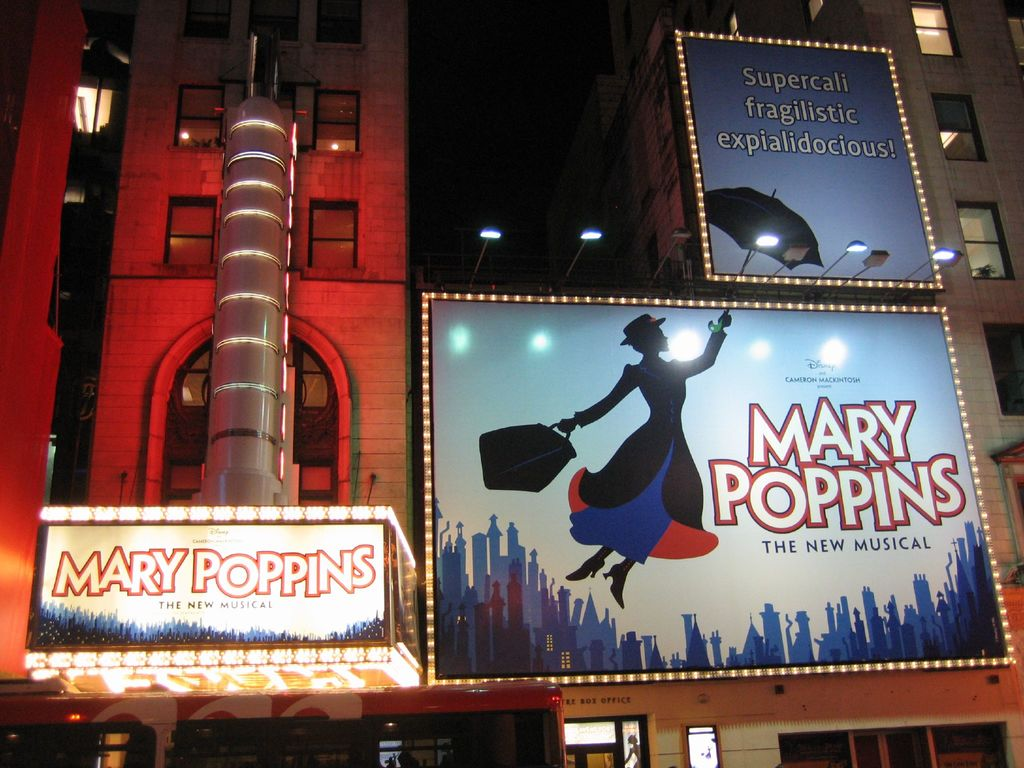What might be the significance of using such vibrant lighting and large billboards for this musical? The vibrant lighting and large billboards play a crucial role in creating a visual allure that captures the attention of passersby and potential audience members. This theatrical marketing strategy not only highlights the musical's presence in a bustling cityscape but also reflects the magical and larger-than-life aspects of the 'Mary Poppins' narrative. Such display tactics evoke excitement and curiosity, drawing in audiences with the promise of a spectacular production that mirrors the enchantment depicted on the billboards. How does this kind of marketing affect audience expectations? This type of marketing sets high audience expectations, as the grandiose and vivid displays suggest an equally impressive theatrical experience. By showcasing key elements of the story and its whimsical themes through dynamic and eye-catching visuals, the marketing ensures that the audience is primed for a high-quality, engaging, and memorable performance that will likely resonate emotionally and aesthetically, aligning with the iconic status of 'Mary Poppins'. 